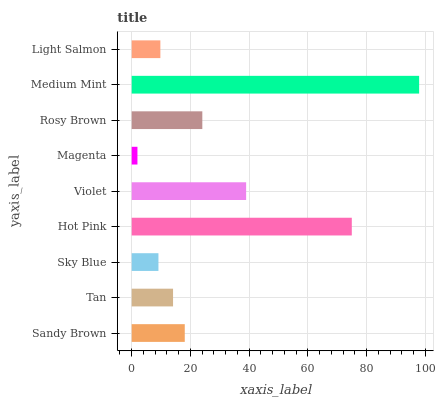Is Magenta the minimum?
Answer yes or no. Yes. Is Medium Mint the maximum?
Answer yes or no. Yes. Is Tan the minimum?
Answer yes or no. No. Is Tan the maximum?
Answer yes or no. No. Is Sandy Brown greater than Tan?
Answer yes or no. Yes. Is Tan less than Sandy Brown?
Answer yes or no. Yes. Is Tan greater than Sandy Brown?
Answer yes or no. No. Is Sandy Brown less than Tan?
Answer yes or no. No. Is Sandy Brown the high median?
Answer yes or no. Yes. Is Sandy Brown the low median?
Answer yes or no. Yes. Is Medium Mint the high median?
Answer yes or no. No. Is Violet the low median?
Answer yes or no. No. 